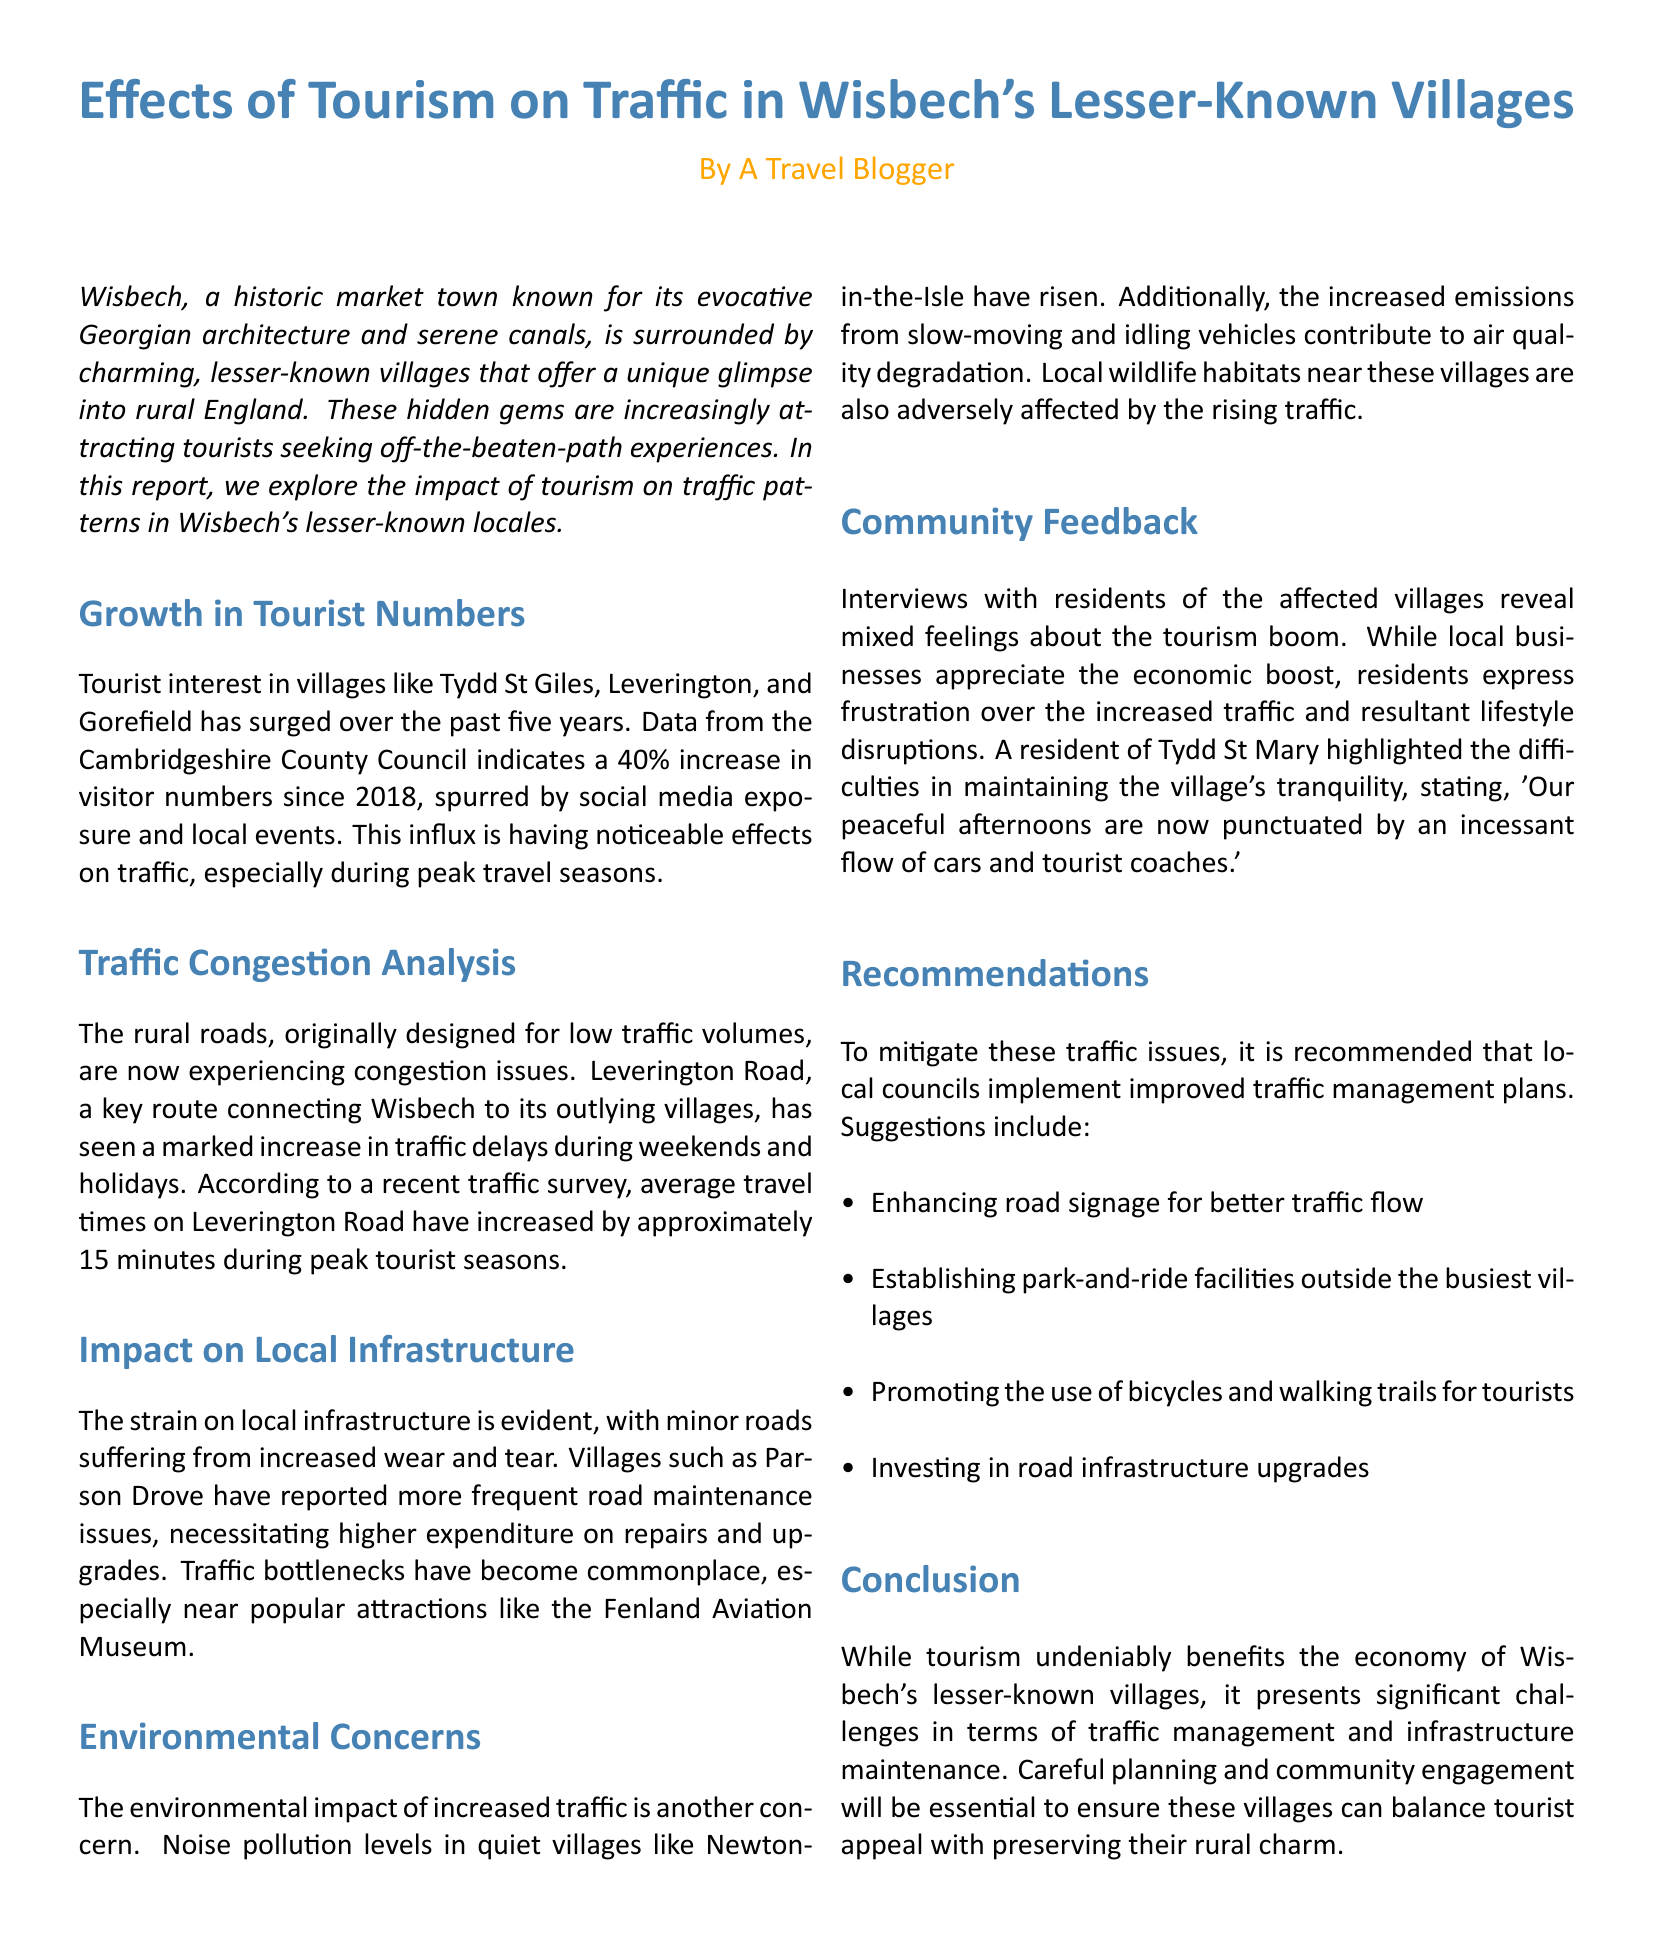what is the percentage increase in visitor numbers since 2018? The report indicates a 40% increase in visitor numbers since 2018.
Answer: 40% which villages are mentioned as experiencing a surge in tourist interest? The report mentions Tydd St Giles, Leverington, and Gorefield as the villages experiencing a surge in tourist interest.
Answer: Tydd St Giles, Leverington, Gorefield how much have average travel times on Leverington Road increased during peak tourist seasons? Average travel times on Leverington Road have increased by approximately 15 minutes during peak tourist seasons.
Answer: 15 minutes what environmental issue has risen in quiet villages like Newton-in-the-Isle? The report mentions that noise pollution levels in Newton-in-the-Isle have risen due to increased traffic.
Answer: Noise pollution what is a suggested recommendation to mitigate traffic issues? One of the recommendations is to establish park-and-ride facilities outside the busiest villages to manage traffic better.
Answer: Park-and-ride facilities how do local businesses feel about the influx of tourists, according to community feedback? Local businesses appreciate the economic boost brought by the influx of tourists.
Answer: Economic boost which road is experiencing congestion due to increased tourist traffic? The report highlights that Leverington Road is experiencing congestion due to increased tourist traffic.
Answer: Leverington Road what is a common frustration expressed by residents regarding increased tourism? Residents express frustration over the increased traffic and resultant lifestyle disruptions caused by tourism.
Answer: Increased traffic what are the names of some villages where traffic bottlenecks have become commonplace? Traffic bottlenecks have become commonplace near popular attractions like the Fenland Aviation Museum and in villages like Parson Drove.
Answer: Parson Drove 